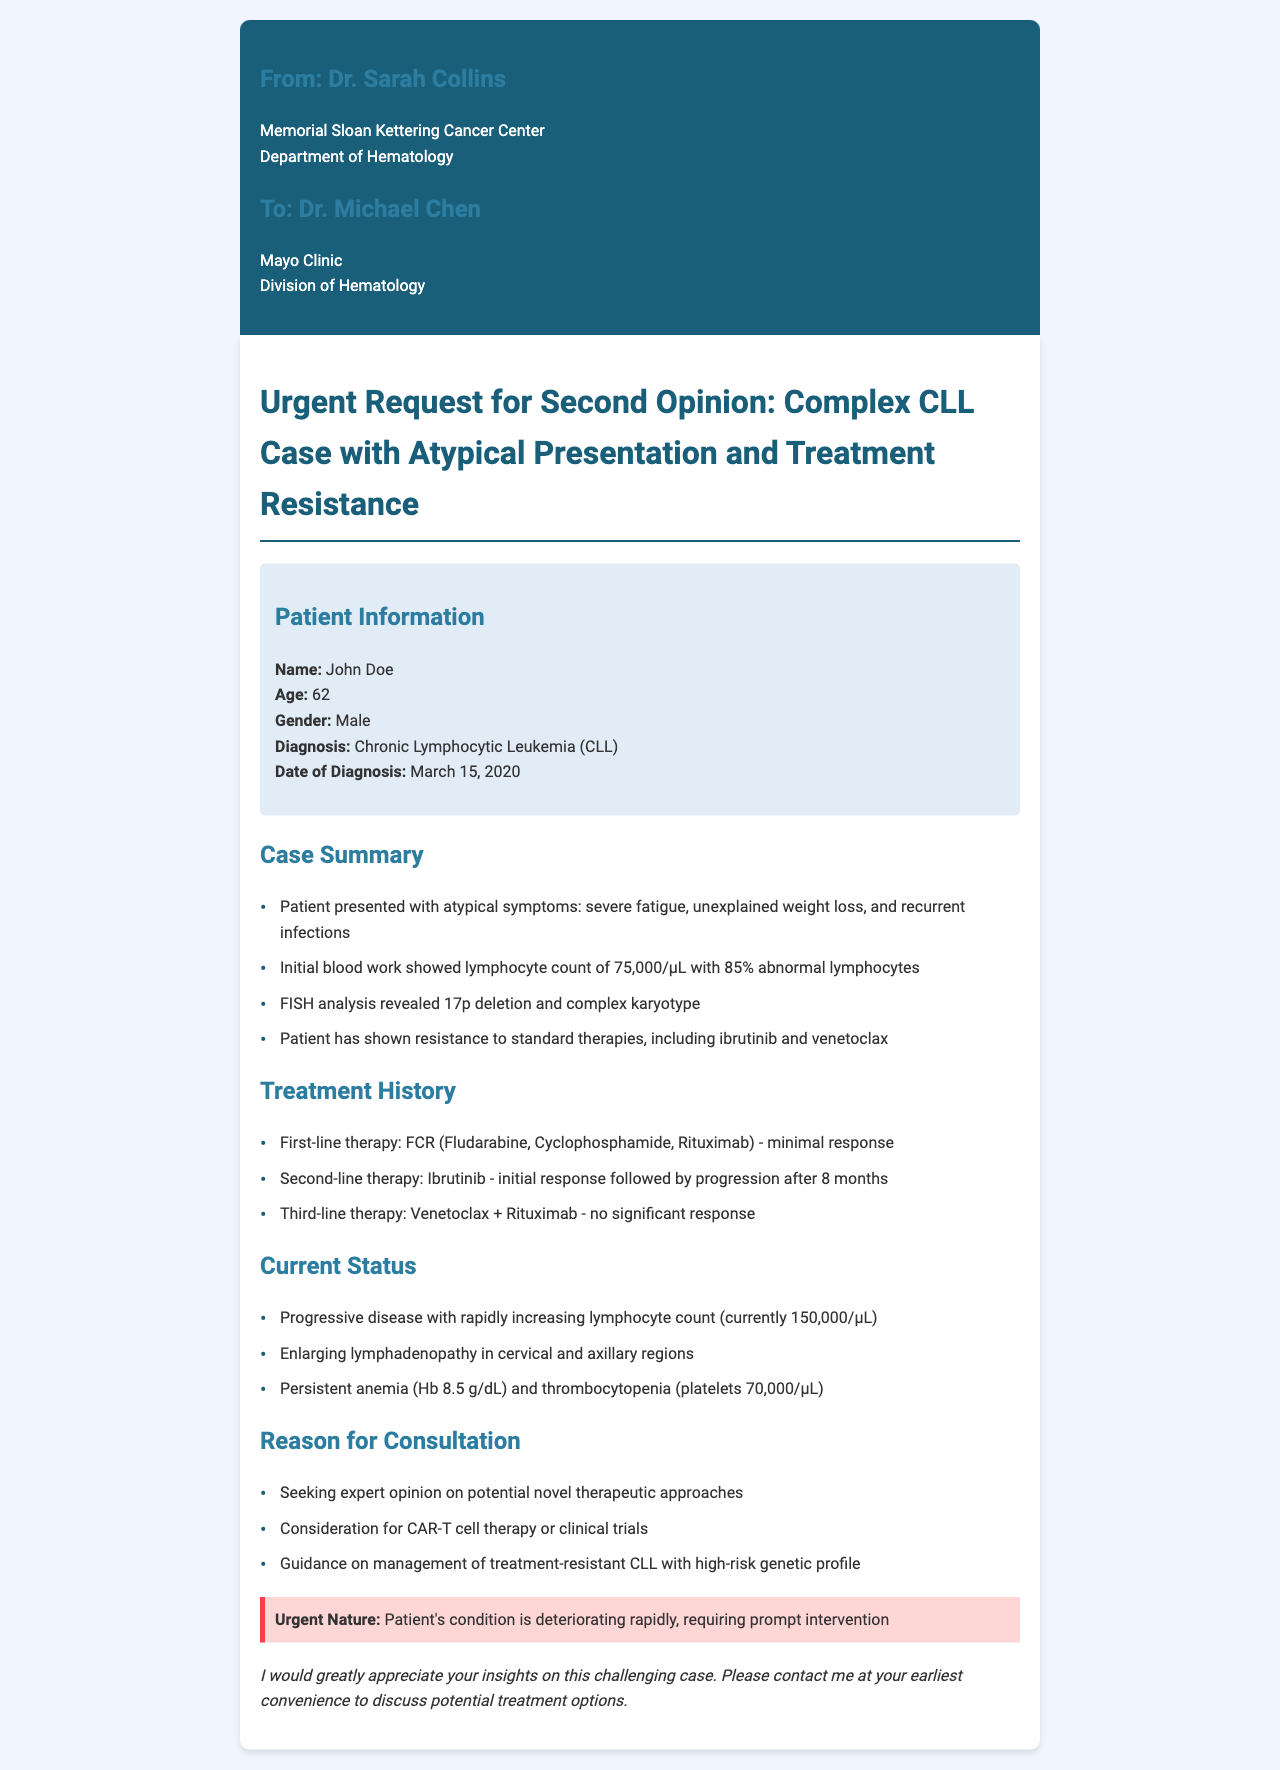What is the patient's name? The patient's name is John Doe.
Answer: John Doe What is the age of the patient? The document states that the patient is 62 years old.
Answer: 62 What treatment did the patient undergo first-line? The first-line therapy mentioned is FCR (Fludarabine, Cyclophosphamide, Rituximab).
Answer: FCR (Fludarabine, Cyclophosphamide, Rituximab) What is the current lymphocyte count? The document indicates that the current lymphocyte count is 150,000/μL.
Answer: 150,000/μL What reason is provided for the consultation? The document states that the reason for consultation includes seeking expert opinion on potential novel therapeutic approaches.
Answer: Seeking expert opinion on potential novel therapeutic approaches How many months did the patient have an initial response to Ibrutinib? The patient had an initial response to Ibrutinib for 8 months before progression.
Answer: 8 months What type of analysis revealed a 17p deletion? The FISH analysis revealed a 17p deletion and complex karyotype.
Answer: FISH analysis What is the urgent nature described for the patient's condition? The document emphasizes that the patient's condition is deteriorating rapidly, requiring prompt intervention.
Answer: Deteriorating rapidly, requiring prompt intervention What guidance is being sought for the management of CLL? Guidance on management of treatment-resistant CLL with high-risk genetic profile is being sought.
Answer: Management of treatment-resistant CLL with high-risk genetic profile 